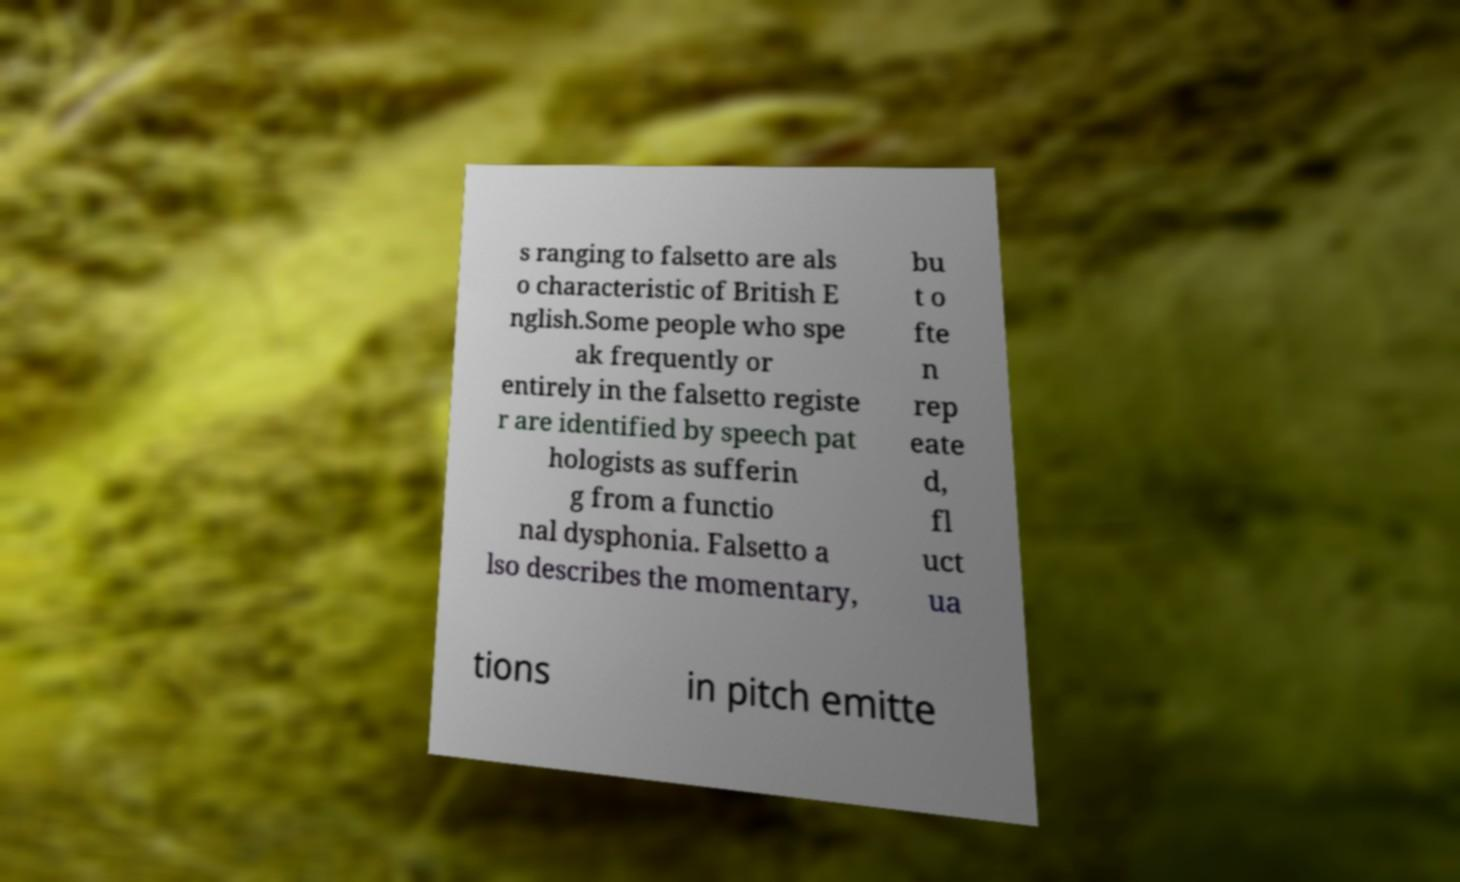There's text embedded in this image that I need extracted. Can you transcribe it verbatim? s ranging to falsetto are als o characteristic of British E nglish.Some people who spe ak frequently or entirely in the falsetto registe r are identified by speech pat hologists as sufferin g from a functio nal dysphonia. Falsetto a lso describes the momentary, bu t o fte n rep eate d, fl uct ua tions in pitch emitte 